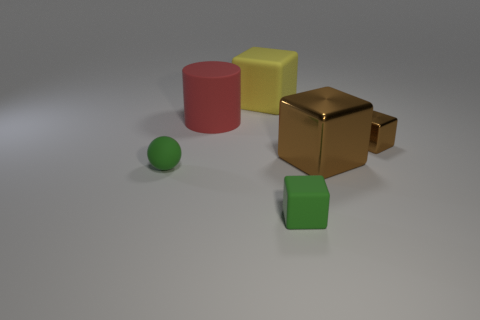There is a ball; are there any tiny brown things behind it?
Keep it short and to the point. Yes. The cube in front of the big metal object is what color?
Offer a very short reply. Green. The tiny object that is in front of the tiny matte thing behind the green matte cube is made of what material?
Provide a succinct answer. Rubber. Are there fewer red objects to the right of the small brown metallic cube than blocks that are in front of the large brown cube?
Your answer should be very brief. Yes. What number of blue objects are either large metallic blocks or cylinders?
Make the answer very short. 0. Are there an equal number of small brown metallic cubes on the right side of the big red matte object and large metal objects?
Offer a terse response. Yes. What number of things are gray matte objects or rubber things that are right of the yellow rubber object?
Provide a short and direct response. 1. Is the cylinder the same color as the small shiny cube?
Provide a succinct answer. No. Are there any spheres made of the same material as the red thing?
Make the answer very short. Yes. The big rubber thing that is the same shape as the small shiny thing is what color?
Your response must be concise. Yellow. 